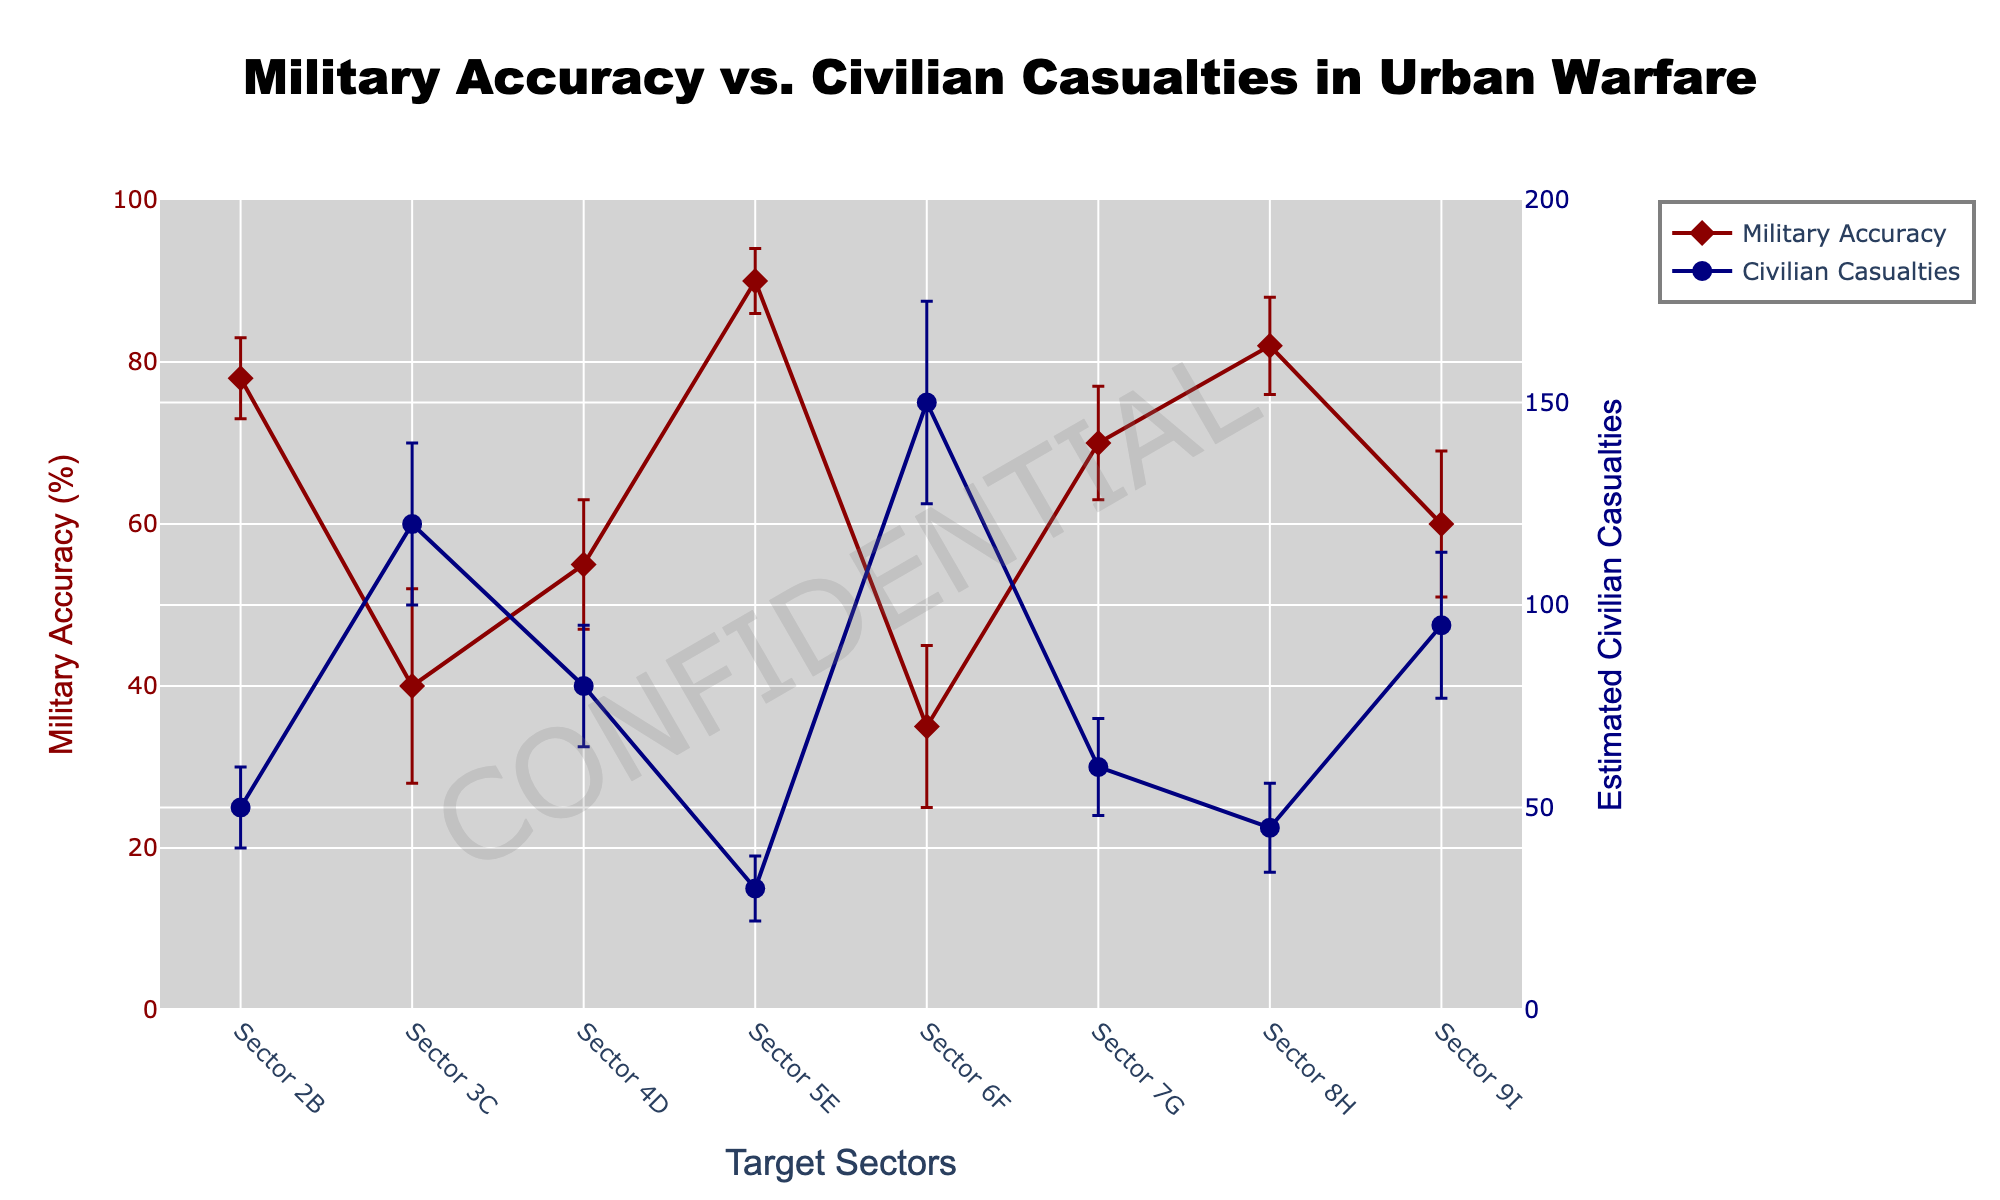What's the title of the figure? The title is located at the top center of the figure and clearly states the primary focus of the plot.
Answer: Military Accuracy vs. Civilian Casualties in Urban Warfare What are the colors used for Military Accuracy and Civilian Casualties? By observing the markers and lines, Military Accuracy is represented in dark red, while Civilian Casualties is shown in navy.
Answer: dark red, navy How many data points are shown in the figure? Count the discrete markers for each line to determine the number of data points. Both series show the same number of markers.
Answer: 8 Which sector has the highest military accuracy? Look at the military accuracy line (dark red) and find the highest point, which corresponds to Sector 5E at 90%.
Answer: Sector 5E What is the range of civilian casualties shown in the figure? The range can be determined by noting the minimum and maximum values on the y2-axis (right side). Civilian casualties range from about 30 to 150.
Answer: 30 to 150 Which sector has the lowest estimated civilian casualties, and how much is it? Identify the lowest point on the civilian casualties line (navy) to find Sector 5E with approximately 30 casualties.
Answer: Sector 5E, 30 What's the average estimated accuracy of the military across all sectors? Add all the military accuracy percentages and divide by the number of sectors: (78 + 40 + 55 + 90 + 35 + 70 + 82 + 60)/8 = 63.75%
Answer: 63.75% Compare the accuracy uncertainty in Sector 3C and Sector 9I. Which one is larger? Observe the error bars. Sector 3C has an uncertainty of 12%, while Sector 9I has an uncertainty of 9%, making Sector 3C's uncertainty larger.
Answer: Sector 3C What's the difference in estimated civilian casualties between Sector 6F and Sector 2B? Subtract the casualties in Sector 2B from Sector 6F: 150 - 50 = 100.
Answer: 100 Does the sector with the highest military accuracy also have the lowest uncertainty for accuracy? Sector 5E has the highest accuracy (90%), and its uncertainty (4%) is also the lowest compared to other sectors.
Answer: Yes 